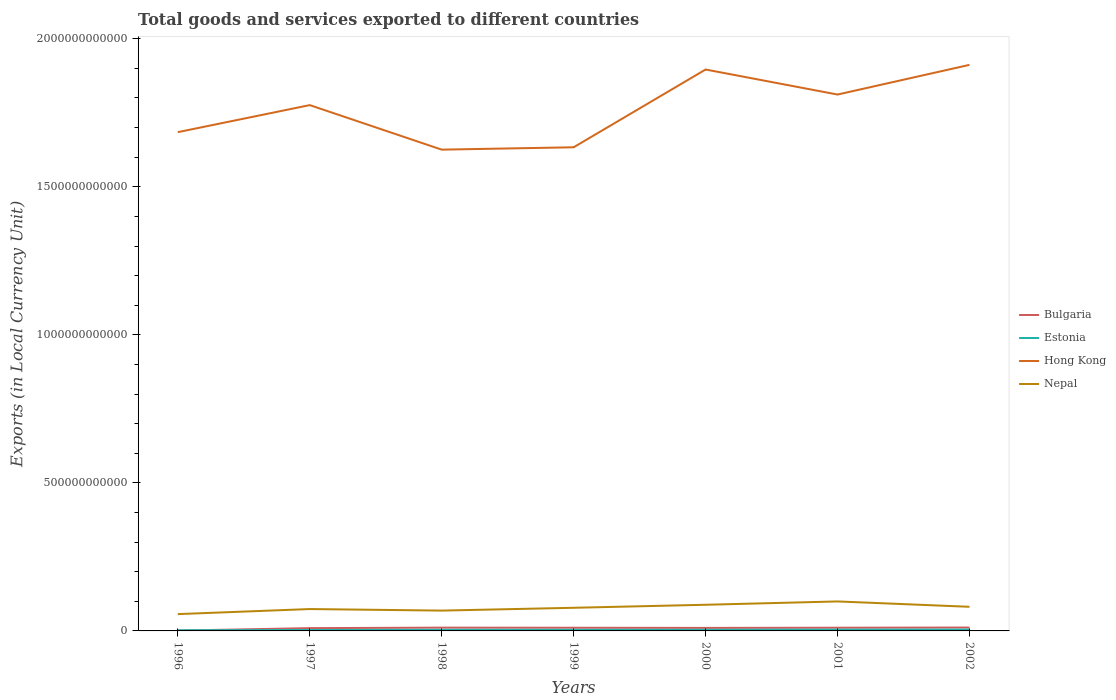Is the number of lines equal to the number of legend labels?
Provide a succinct answer. Yes. Across all years, what is the maximum Amount of goods and services exports in Estonia?
Give a very brief answer. 2.26e+09. In which year was the Amount of goods and services exports in Nepal maximum?
Your answer should be compact. 1996. What is the total Amount of goods and services exports in Bulgaria in the graph?
Provide a short and direct response. 2.89e+08. What is the difference between the highest and the second highest Amount of goods and services exports in Hong Kong?
Keep it short and to the point. 2.86e+11. Is the Amount of goods and services exports in Nepal strictly greater than the Amount of goods and services exports in Estonia over the years?
Provide a short and direct response. No. How many years are there in the graph?
Your response must be concise. 7. What is the difference between two consecutive major ticks on the Y-axis?
Make the answer very short. 5.00e+11. Are the values on the major ticks of Y-axis written in scientific E-notation?
Provide a short and direct response. No. Does the graph contain grids?
Offer a very short reply. No. Where does the legend appear in the graph?
Your answer should be very brief. Center right. What is the title of the graph?
Ensure brevity in your answer.  Total goods and services exported to different countries. What is the label or title of the Y-axis?
Ensure brevity in your answer.  Exports (in Local Currency Unit). What is the Exports (in Local Currency Unit) of Bulgaria in 1996?
Your answer should be very brief. 1.06e+09. What is the Exports (in Local Currency Unit) of Estonia in 1996?
Make the answer very short. 2.26e+09. What is the Exports (in Local Currency Unit) of Hong Kong in 1996?
Make the answer very short. 1.68e+12. What is the Exports (in Local Currency Unit) in Nepal in 1996?
Give a very brief answer. 5.68e+1. What is the Exports (in Local Currency Unit) in Bulgaria in 1997?
Give a very brief answer. 9.44e+09. What is the Exports (in Local Currency Unit) of Estonia in 1997?
Offer a very short reply. 3.22e+09. What is the Exports (in Local Currency Unit) of Hong Kong in 1997?
Provide a short and direct response. 1.78e+12. What is the Exports (in Local Currency Unit) of Nepal in 1997?
Offer a very short reply. 7.39e+1. What is the Exports (in Local Currency Unit) of Bulgaria in 1998?
Ensure brevity in your answer.  1.11e+1. What is the Exports (in Local Currency Unit) of Estonia in 1998?
Make the answer very short. 3.76e+09. What is the Exports (in Local Currency Unit) of Hong Kong in 1998?
Ensure brevity in your answer.  1.63e+12. What is the Exports (in Local Currency Unit) of Nepal in 1998?
Provide a short and direct response. 6.87e+1. What is the Exports (in Local Currency Unit) in Bulgaria in 1999?
Provide a short and direct response. 1.07e+1. What is the Exports (in Local Currency Unit) in Estonia in 1999?
Make the answer very short. 3.78e+09. What is the Exports (in Local Currency Unit) of Hong Kong in 1999?
Provide a short and direct response. 1.63e+12. What is the Exports (in Local Currency Unit) of Nepal in 1999?
Your response must be concise. 7.82e+1. What is the Exports (in Local Currency Unit) of Bulgaria in 2000?
Your answer should be compact. 1.02e+1. What is the Exports (in Local Currency Unit) in Estonia in 2000?
Your answer should be very brief. 3.80e+09. What is the Exports (in Local Currency Unit) in Hong Kong in 2000?
Ensure brevity in your answer.  1.90e+12. What is the Exports (in Local Currency Unit) of Nepal in 2000?
Your response must be concise. 8.84e+1. What is the Exports (in Local Currency Unit) in Bulgaria in 2001?
Your answer should be compact. 1.08e+1. What is the Exports (in Local Currency Unit) in Estonia in 2001?
Your answer should be compact. 4.28e+09. What is the Exports (in Local Currency Unit) in Hong Kong in 2001?
Give a very brief answer. 1.81e+12. What is the Exports (in Local Currency Unit) of Nepal in 2001?
Your answer should be compact. 9.96e+1. What is the Exports (in Local Currency Unit) of Bulgaria in 2002?
Your answer should be very brief. 1.15e+1. What is the Exports (in Local Currency Unit) of Estonia in 2002?
Your answer should be compact. 4.53e+09. What is the Exports (in Local Currency Unit) in Hong Kong in 2002?
Your response must be concise. 1.91e+12. What is the Exports (in Local Currency Unit) in Nepal in 2002?
Offer a terse response. 8.15e+1. Across all years, what is the maximum Exports (in Local Currency Unit) of Bulgaria?
Offer a very short reply. 1.15e+1. Across all years, what is the maximum Exports (in Local Currency Unit) in Estonia?
Provide a short and direct response. 4.53e+09. Across all years, what is the maximum Exports (in Local Currency Unit) in Hong Kong?
Provide a short and direct response. 1.91e+12. Across all years, what is the maximum Exports (in Local Currency Unit) in Nepal?
Offer a terse response. 9.96e+1. Across all years, what is the minimum Exports (in Local Currency Unit) in Bulgaria?
Offer a very short reply. 1.06e+09. Across all years, what is the minimum Exports (in Local Currency Unit) in Estonia?
Offer a very short reply. 2.26e+09. Across all years, what is the minimum Exports (in Local Currency Unit) of Hong Kong?
Your answer should be very brief. 1.63e+12. Across all years, what is the minimum Exports (in Local Currency Unit) in Nepal?
Provide a short and direct response. 5.68e+1. What is the total Exports (in Local Currency Unit) of Bulgaria in the graph?
Ensure brevity in your answer.  6.48e+1. What is the total Exports (in Local Currency Unit) of Estonia in the graph?
Ensure brevity in your answer.  2.56e+1. What is the total Exports (in Local Currency Unit) of Hong Kong in the graph?
Keep it short and to the point. 1.23e+13. What is the total Exports (in Local Currency Unit) in Nepal in the graph?
Offer a very short reply. 5.47e+11. What is the difference between the Exports (in Local Currency Unit) of Bulgaria in 1996 and that in 1997?
Give a very brief answer. -8.37e+09. What is the difference between the Exports (in Local Currency Unit) of Estonia in 1996 and that in 1997?
Offer a very short reply. -9.64e+08. What is the difference between the Exports (in Local Currency Unit) in Hong Kong in 1996 and that in 1997?
Ensure brevity in your answer.  -9.13e+1. What is the difference between the Exports (in Local Currency Unit) in Nepal in 1996 and that in 1997?
Keep it short and to the point. -1.71e+1. What is the difference between the Exports (in Local Currency Unit) of Bulgaria in 1996 and that in 1998?
Make the answer very short. -1.00e+1. What is the difference between the Exports (in Local Currency Unit) of Estonia in 1996 and that in 1998?
Ensure brevity in your answer.  -1.50e+09. What is the difference between the Exports (in Local Currency Unit) in Hong Kong in 1996 and that in 1998?
Provide a succinct answer. 5.90e+1. What is the difference between the Exports (in Local Currency Unit) in Nepal in 1996 and that in 1998?
Your answer should be compact. -1.19e+1. What is the difference between the Exports (in Local Currency Unit) of Bulgaria in 1996 and that in 1999?
Provide a short and direct response. -9.65e+09. What is the difference between the Exports (in Local Currency Unit) in Estonia in 1996 and that in 1999?
Provide a succinct answer. -1.52e+09. What is the difference between the Exports (in Local Currency Unit) of Hong Kong in 1996 and that in 1999?
Give a very brief answer. 5.11e+1. What is the difference between the Exports (in Local Currency Unit) of Nepal in 1996 and that in 1999?
Make the answer very short. -2.14e+1. What is the difference between the Exports (in Local Currency Unit) in Bulgaria in 1996 and that in 2000?
Offer a very short reply. -9.13e+09. What is the difference between the Exports (in Local Currency Unit) of Estonia in 1996 and that in 2000?
Your answer should be very brief. -1.55e+09. What is the difference between the Exports (in Local Currency Unit) of Hong Kong in 1996 and that in 2000?
Provide a short and direct response. -2.12e+11. What is the difference between the Exports (in Local Currency Unit) in Nepal in 1996 and that in 2000?
Your answer should be compact. -3.16e+1. What is the difference between the Exports (in Local Currency Unit) in Bulgaria in 1996 and that in 2001?
Provide a succinct answer. -9.75e+09. What is the difference between the Exports (in Local Currency Unit) of Estonia in 1996 and that in 2001?
Make the answer very short. -2.02e+09. What is the difference between the Exports (in Local Currency Unit) of Hong Kong in 1996 and that in 2001?
Make the answer very short. -1.27e+11. What is the difference between the Exports (in Local Currency Unit) of Nepal in 1996 and that in 2001?
Offer a very short reply. -4.28e+1. What is the difference between the Exports (in Local Currency Unit) of Bulgaria in 1996 and that in 2002?
Offer a terse response. -1.04e+1. What is the difference between the Exports (in Local Currency Unit) of Estonia in 1996 and that in 2002?
Make the answer very short. -2.28e+09. What is the difference between the Exports (in Local Currency Unit) in Hong Kong in 1996 and that in 2002?
Provide a short and direct response. -2.27e+11. What is the difference between the Exports (in Local Currency Unit) of Nepal in 1996 and that in 2002?
Your response must be concise. -2.47e+1. What is the difference between the Exports (in Local Currency Unit) in Bulgaria in 1997 and that in 1998?
Your response must be concise. -1.66e+09. What is the difference between the Exports (in Local Currency Unit) of Estonia in 1997 and that in 1998?
Make the answer very short. -5.37e+08. What is the difference between the Exports (in Local Currency Unit) in Hong Kong in 1997 and that in 1998?
Offer a terse response. 1.50e+11. What is the difference between the Exports (in Local Currency Unit) of Nepal in 1997 and that in 1998?
Keep it short and to the point. 5.19e+09. What is the difference between the Exports (in Local Currency Unit) of Bulgaria in 1997 and that in 1999?
Give a very brief answer. -1.27e+09. What is the difference between the Exports (in Local Currency Unit) in Estonia in 1997 and that in 1999?
Provide a short and direct response. -5.59e+08. What is the difference between the Exports (in Local Currency Unit) of Hong Kong in 1997 and that in 1999?
Provide a succinct answer. 1.42e+11. What is the difference between the Exports (in Local Currency Unit) of Nepal in 1997 and that in 1999?
Keep it short and to the point. -4.30e+09. What is the difference between the Exports (in Local Currency Unit) in Bulgaria in 1997 and that in 2000?
Your answer should be compact. -7.51e+08. What is the difference between the Exports (in Local Currency Unit) of Estonia in 1997 and that in 2000?
Give a very brief answer. -5.85e+08. What is the difference between the Exports (in Local Currency Unit) of Hong Kong in 1997 and that in 2000?
Your response must be concise. -1.20e+11. What is the difference between the Exports (in Local Currency Unit) of Nepal in 1997 and that in 2000?
Ensure brevity in your answer.  -1.45e+1. What is the difference between the Exports (in Local Currency Unit) in Bulgaria in 1997 and that in 2001?
Your response must be concise. -1.37e+09. What is the difference between the Exports (in Local Currency Unit) of Estonia in 1997 and that in 2001?
Your response must be concise. -1.06e+09. What is the difference between the Exports (in Local Currency Unit) of Hong Kong in 1997 and that in 2001?
Keep it short and to the point. -3.57e+1. What is the difference between the Exports (in Local Currency Unit) in Nepal in 1997 and that in 2001?
Your response must be concise. -2.57e+1. What is the difference between the Exports (in Local Currency Unit) in Bulgaria in 1997 and that in 2002?
Make the answer very short. -2.03e+09. What is the difference between the Exports (in Local Currency Unit) of Estonia in 1997 and that in 2002?
Keep it short and to the point. -1.32e+09. What is the difference between the Exports (in Local Currency Unit) in Hong Kong in 1997 and that in 2002?
Offer a terse response. -1.36e+11. What is the difference between the Exports (in Local Currency Unit) in Nepal in 1997 and that in 2002?
Offer a very short reply. -7.64e+09. What is the difference between the Exports (in Local Currency Unit) in Bulgaria in 1998 and that in 1999?
Give a very brief answer. 3.92e+08. What is the difference between the Exports (in Local Currency Unit) of Estonia in 1998 and that in 1999?
Give a very brief answer. -2.19e+07. What is the difference between the Exports (in Local Currency Unit) in Hong Kong in 1998 and that in 1999?
Your answer should be very brief. -7.95e+09. What is the difference between the Exports (in Local Currency Unit) of Nepal in 1998 and that in 1999?
Offer a terse response. -9.49e+09. What is the difference between the Exports (in Local Currency Unit) of Bulgaria in 1998 and that in 2000?
Your response must be concise. 9.11e+08. What is the difference between the Exports (in Local Currency Unit) of Estonia in 1998 and that in 2000?
Offer a terse response. -4.78e+07. What is the difference between the Exports (in Local Currency Unit) in Hong Kong in 1998 and that in 2000?
Make the answer very short. -2.71e+11. What is the difference between the Exports (in Local Currency Unit) of Nepal in 1998 and that in 2000?
Ensure brevity in your answer.  -1.97e+1. What is the difference between the Exports (in Local Currency Unit) in Bulgaria in 1998 and that in 2001?
Ensure brevity in your answer.  2.89e+08. What is the difference between the Exports (in Local Currency Unit) in Estonia in 1998 and that in 2001?
Your answer should be very brief. -5.24e+08. What is the difference between the Exports (in Local Currency Unit) of Hong Kong in 1998 and that in 2001?
Give a very brief answer. -1.86e+11. What is the difference between the Exports (in Local Currency Unit) of Nepal in 1998 and that in 2001?
Provide a short and direct response. -3.09e+1. What is the difference between the Exports (in Local Currency Unit) in Bulgaria in 1998 and that in 2002?
Your response must be concise. -3.66e+08. What is the difference between the Exports (in Local Currency Unit) in Estonia in 1998 and that in 2002?
Offer a terse response. -7.78e+08. What is the difference between the Exports (in Local Currency Unit) in Hong Kong in 1998 and that in 2002?
Provide a short and direct response. -2.86e+11. What is the difference between the Exports (in Local Currency Unit) of Nepal in 1998 and that in 2002?
Offer a very short reply. -1.28e+1. What is the difference between the Exports (in Local Currency Unit) of Bulgaria in 1999 and that in 2000?
Provide a short and direct response. 5.19e+08. What is the difference between the Exports (in Local Currency Unit) of Estonia in 1999 and that in 2000?
Offer a terse response. -2.58e+07. What is the difference between the Exports (in Local Currency Unit) in Hong Kong in 1999 and that in 2000?
Make the answer very short. -2.63e+11. What is the difference between the Exports (in Local Currency Unit) of Nepal in 1999 and that in 2000?
Make the answer very short. -1.02e+1. What is the difference between the Exports (in Local Currency Unit) of Bulgaria in 1999 and that in 2001?
Your response must be concise. -1.03e+08. What is the difference between the Exports (in Local Currency Unit) in Estonia in 1999 and that in 2001?
Give a very brief answer. -5.02e+08. What is the difference between the Exports (in Local Currency Unit) of Hong Kong in 1999 and that in 2001?
Provide a short and direct response. -1.78e+11. What is the difference between the Exports (in Local Currency Unit) in Nepal in 1999 and that in 2001?
Provide a short and direct response. -2.14e+1. What is the difference between the Exports (in Local Currency Unit) in Bulgaria in 1999 and that in 2002?
Provide a short and direct response. -7.57e+08. What is the difference between the Exports (in Local Currency Unit) of Estonia in 1999 and that in 2002?
Your response must be concise. -7.56e+08. What is the difference between the Exports (in Local Currency Unit) of Hong Kong in 1999 and that in 2002?
Your answer should be very brief. -2.78e+11. What is the difference between the Exports (in Local Currency Unit) in Nepal in 1999 and that in 2002?
Make the answer very short. -3.34e+09. What is the difference between the Exports (in Local Currency Unit) of Bulgaria in 2000 and that in 2001?
Ensure brevity in your answer.  -6.22e+08. What is the difference between the Exports (in Local Currency Unit) in Estonia in 2000 and that in 2001?
Ensure brevity in your answer.  -4.76e+08. What is the difference between the Exports (in Local Currency Unit) of Hong Kong in 2000 and that in 2001?
Keep it short and to the point. 8.45e+1. What is the difference between the Exports (in Local Currency Unit) of Nepal in 2000 and that in 2001?
Keep it short and to the point. -1.12e+1. What is the difference between the Exports (in Local Currency Unit) in Bulgaria in 2000 and that in 2002?
Provide a succinct answer. -1.28e+09. What is the difference between the Exports (in Local Currency Unit) in Estonia in 2000 and that in 2002?
Your response must be concise. -7.30e+08. What is the difference between the Exports (in Local Currency Unit) of Hong Kong in 2000 and that in 2002?
Provide a succinct answer. -1.57e+1. What is the difference between the Exports (in Local Currency Unit) of Nepal in 2000 and that in 2002?
Provide a short and direct response. 6.87e+09. What is the difference between the Exports (in Local Currency Unit) in Bulgaria in 2001 and that in 2002?
Keep it short and to the point. -6.55e+08. What is the difference between the Exports (in Local Currency Unit) in Estonia in 2001 and that in 2002?
Provide a short and direct response. -2.54e+08. What is the difference between the Exports (in Local Currency Unit) in Hong Kong in 2001 and that in 2002?
Your answer should be compact. -1.00e+11. What is the difference between the Exports (in Local Currency Unit) in Nepal in 2001 and that in 2002?
Provide a succinct answer. 1.81e+1. What is the difference between the Exports (in Local Currency Unit) of Bulgaria in 1996 and the Exports (in Local Currency Unit) of Estonia in 1997?
Ensure brevity in your answer.  -2.16e+09. What is the difference between the Exports (in Local Currency Unit) in Bulgaria in 1996 and the Exports (in Local Currency Unit) in Hong Kong in 1997?
Offer a terse response. -1.77e+12. What is the difference between the Exports (in Local Currency Unit) of Bulgaria in 1996 and the Exports (in Local Currency Unit) of Nepal in 1997?
Ensure brevity in your answer.  -7.28e+1. What is the difference between the Exports (in Local Currency Unit) in Estonia in 1996 and the Exports (in Local Currency Unit) in Hong Kong in 1997?
Your answer should be compact. -1.77e+12. What is the difference between the Exports (in Local Currency Unit) in Estonia in 1996 and the Exports (in Local Currency Unit) in Nepal in 1997?
Ensure brevity in your answer.  -7.16e+1. What is the difference between the Exports (in Local Currency Unit) of Hong Kong in 1996 and the Exports (in Local Currency Unit) of Nepal in 1997?
Offer a very short reply. 1.61e+12. What is the difference between the Exports (in Local Currency Unit) in Bulgaria in 1996 and the Exports (in Local Currency Unit) in Estonia in 1998?
Give a very brief answer. -2.69e+09. What is the difference between the Exports (in Local Currency Unit) in Bulgaria in 1996 and the Exports (in Local Currency Unit) in Hong Kong in 1998?
Offer a terse response. -1.62e+12. What is the difference between the Exports (in Local Currency Unit) of Bulgaria in 1996 and the Exports (in Local Currency Unit) of Nepal in 1998?
Keep it short and to the point. -6.76e+1. What is the difference between the Exports (in Local Currency Unit) in Estonia in 1996 and the Exports (in Local Currency Unit) in Hong Kong in 1998?
Give a very brief answer. -1.62e+12. What is the difference between the Exports (in Local Currency Unit) in Estonia in 1996 and the Exports (in Local Currency Unit) in Nepal in 1998?
Offer a very short reply. -6.64e+1. What is the difference between the Exports (in Local Currency Unit) in Hong Kong in 1996 and the Exports (in Local Currency Unit) in Nepal in 1998?
Make the answer very short. 1.62e+12. What is the difference between the Exports (in Local Currency Unit) of Bulgaria in 1996 and the Exports (in Local Currency Unit) of Estonia in 1999?
Make the answer very short. -2.72e+09. What is the difference between the Exports (in Local Currency Unit) of Bulgaria in 1996 and the Exports (in Local Currency Unit) of Hong Kong in 1999?
Your answer should be very brief. -1.63e+12. What is the difference between the Exports (in Local Currency Unit) of Bulgaria in 1996 and the Exports (in Local Currency Unit) of Nepal in 1999?
Give a very brief answer. -7.71e+1. What is the difference between the Exports (in Local Currency Unit) in Estonia in 1996 and the Exports (in Local Currency Unit) in Hong Kong in 1999?
Offer a very short reply. -1.63e+12. What is the difference between the Exports (in Local Currency Unit) of Estonia in 1996 and the Exports (in Local Currency Unit) of Nepal in 1999?
Make the answer very short. -7.59e+1. What is the difference between the Exports (in Local Currency Unit) of Hong Kong in 1996 and the Exports (in Local Currency Unit) of Nepal in 1999?
Make the answer very short. 1.61e+12. What is the difference between the Exports (in Local Currency Unit) of Bulgaria in 1996 and the Exports (in Local Currency Unit) of Estonia in 2000?
Keep it short and to the point. -2.74e+09. What is the difference between the Exports (in Local Currency Unit) in Bulgaria in 1996 and the Exports (in Local Currency Unit) in Hong Kong in 2000?
Give a very brief answer. -1.90e+12. What is the difference between the Exports (in Local Currency Unit) in Bulgaria in 1996 and the Exports (in Local Currency Unit) in Nepal in 2000?
Provide a short and direct response. -8.73e+1. What is the difference between the Exports (in Local Currency Unit) of Estonia in 1996 and the Exports (in Local Currency Unit) of Hong Kong in 2000?
Your response must be concise. -1.89e+12. What is the difference between the Exports (in Local Currency Unit) in Estonia in 1996 and the Exports (in Local Currency Unit) in Nepal in 2000?
Ensure brevity in your answer.  -8.61e+1. What is the difference between the Exports (in Local Currency Unit) in Hong Kong in 1996 and the Exports (in Local Currency Unit) in Nepal in 2000?
Ensure brevity in your answer.  1.60e+12. What is the difference between the Exports (in Local Currency Unit) in Bulgaria in 1996 and the Exports (in Local Currency Unit) in Estonia in 2001?
Offer a terse response. -3.22e+09. What is the difference between the Exports (in Local Currency Unit) of Bulgaria in 1996 and the Exports (in Local Currency Unit) of Hong Kong in 2001?
Provide a short and direct response. -1.81e+12. What is the difference between the Exports (in Local Currency Unit) in Bulgaria in 1996 and the Exports (in Local Currency Unit) in Nepal in 2001?
Offer a terse response. -9.85e+1. What is the difference between the Exports (in Local Currency Unit) in Estonia in 1996 and the Exports (in Local Currency Unit) in Hong Kong in 2001?
Ensure brevity in your answer.  -1.81e+12. What is the difference between the Exports (in Local Currency Unit) in Estonia in 1996 and the Exports (in Local Currency Unit) in Nepal in 2001?
Provide a short and direct response. -9.73e+1. What is the difference between the Exports (in Local Currency Unit) in Hong Kong in 1996 and the Exports (in Local Currency Unit) in Nepal in 2001?
Make the answer very short. 1.58e+12. What is the difference between the Exports (in Local Currency Unit) in Bulgaria in 1996 and the Exports (in Local Currency Unit) in Estonia in 2002?
Your answer should be very brief. -3.47e+09. What is the difference between the Exports (in Local Currency Unit) in Bulgaria in 1996 and the Exports (in Local Currency Unit) in Hong Kong in 2002?
Your response must be concise. -1.91e+12. What is the difference between the Exports (in Local Currency Unit) of Bulgaria in 1996 and the Exports (in Local Currency Unit) of Nepal in 2002?
Offer a terse response. -8.04e+1. What is the difference between the Exports (in Local Currency Unit) of Estonia in 1996 and the Exports (in Local Currency Unit) of Hong Kong in 2002?
Offer a terse response. -1.91e+12. What is the difference between the Exports (in Local Currency Unit) in Estonia in 1996 and the Exports (in Local Currency Unit) in Nepal in 2002?
Your response must be concise. -7.92e+1. What is the difference between the Exports (in Local Currency Unit) in Hong Kong in 1996 and the Exports (in Local Currency Unit) in Nepal in 2002?
Provide a short and direct response. 1.60e+12. What is the difference between the Exports (in Local Currency Unit) in Bulgaria in 1997 and the Exports (in Local Currency Unit) in Estonia in 1998?
Offer a very short reply. 5.68e+09. What is the difference between the Exports (in Local Currency Unit) in Bulgaria in 1997 and the Exports (in Local Currency Unit) in Hong Kong in 1998?
Your response must be concise. -1.62e+12. What is the difference between the Exports (in Local Currency Unit) of Bulgaria in 1997 and the Exports (in Local Currency Unit) of Nepal in 1998?
Your response must be concise. -5.92e+1. What is the difference between the Exports (in Local Currency Unit) in Estonia in 1997 and the Exports (in Local Currency Unit) in Hong Kong in 1998?
Make the answer very short. -1.62e+12. What is the difference between the Exports (in Local Currency Unit) in Estonia in 1997 and the Exports (in Local Currency Unit) in Nepal in 1998?
Your answer should be very brief. -6.54e+1. What is the difference between the Exports (in Local Currency Unit) in Hong Kong in 1997 and the Exports (in Local Currency Unit) in Nepal in 1998?
Your response must be concise. 1.71e+12. What is the difference between the Exports (in Local Currency Unit) of Bulgaria in 1997 and the Exports (in Local Currency Unit) of Estonia in 1999?
Keep it short and to the point. 5.66e+09. What is the difference between the Exports (in Local Currency Unit) of Bulgaria in 1997 and the Exports (in Local Currency Unit) of Hong Kong in 1999?
Offer a very short reply. -1.62e+12. What is the difference between the Exports (in Local Currency Unit) of Bulgaria in 1997 and the Exports (in Local Currency Unit) of Nepal in 1999?
Provide a short and direct response. -6.87e+1. What is the difference between the Exports (in Local Currency Unit) of Estonia in 1997 and the Exports (in Local Currency Unit) of Hong Kong in 1999?
Give a very brief answer. -1.63e+12. What is the difference between the Exports (in Local Currency Unit) of Estonia in 1997 and the Exports (in Local Currency Unit) of Nepal in 1999?
Keep it short and to the point. -7.49e+1. What is the difference between the Exports (in Local Currency Unit) of Hong Kong in 1997 and the Exports (in Local Currency Unit) of Nepal in 1999?
Your response must be concise. 1.70e+12. What is the difference between the Exports (in Local Currency Unit) of Bulgaria in 1997 and the Exports (in Local Currency Unit) of Estonia in 2000?
Offer a terse response. 5.63e+09. What is the difference between the Exports (in Local Currency Unit) of Bulgaria in 1997 and the Exports (in Local Currency Unit) of Hong Kong in 2000?
Your answer should be compact. -1.89e+12. What is the difference between the Exports (in Local Currency Unit) in Bulgaria in 1997 and the Exports (in Local Currency Unit) in Nepal in 2000?
Offer a very short reply. -7.89e+1. What is the difference between the Exports (in Local Currency Unit) of Estonia in 1997 and the Exports (in Local Currency Unit) of Hong Kong in 2000?
Offer a terse response. -1.89e+12. What is the difference between the Exports (in Local Currency Unit) of Estonia in 1997 and the Exports (in Local Currency Unit) of Nepal in 2000?
Offer a terse response. -8.51e+1. What is the difference between the Exports (in Local Currency Unit) in Hong Kong in 1997 and the Exports (in Local Currency Unit) in Nepal in 2000?
Give a very brief answer. 1.69e+12. What is the difference between the Exports (in Local Currency Unit) of Bulgaria in 1997 and the Exports (in Local Currency Unit) of Estonia in 2001?
Provide a short and direct response. 5.16e+09. What is the difference between the Exports (in Local Currency Unit) of Bulgaria in 1997 and the Exports (in Local Currency Unit) of Hong Kong in 2001?
Your answer should be very brief. -1.80e+12. What is the difference between the Exports (in Local Currency Unit) of Bulgaria in 1997 and the Exports (in Local Currency Unit) of Nepal in 2001?
Give a very brief answer. -9.01e+1. What is the difference between the Exports (in Local Currency Unit) in Estonia in 1997 and the Exports (in Local Currency Unit) in Hong Kong in 2001?
Give a very brief answer. -1.81e+12. What is the difference between the Exports (in Local Currency Unit) in Estonia in 1997 and the Exports (in Local Currency Unit) in Nepal in 2001?
Make the answer very short. -9.64e+1. What is the difference between the Exports (in Local Currency Unit) of Hong Kong in 1997 and the Exports (in Local Currency Unit) of Nepal in 2001?
Provide a succinct answer. 1.68e+12. What is the difference between the Exports (in Local Currency Unit) of Bulgaria in 1997 and the Exports (in Local Currency Unit) of Estonia in 2002?
Your response must be concise. 4.90e+09. What is the difference between the Exports (in Local Currency Unit) of Bulgaria in 1997 and the Exports (in Local Currency Unit) of Hong Kong in 2002?
Provide a succinct answer. -1.90e+12. What is the difference between the Exports (in Local Currency Unit) in Bulgaria in 1997 and the Exports (in Local Currency Unit) in Nepal in 2002?
Provide a succinct answer. -7.21e+1. What is the difference between the Exports (in Local Currency Unit) in Estonia in 1997 and the Exports (in Local Currency Unit) in Hong Kong in 2002?
Your response must be concise. -1.91e+12. What is the difference between the Exports (in Local Currency Unit) in Estonia in 1997 and the Exports (in Local Currency Unit) in Nepal in 2002?
Offer a very short reply. -7.83e+1. What is the difference between the Exports (in Local Currency Unit) of Hong Kong in 1997 and the Exports (in Local Currency Unit) of Nepal in 2002?
Offer a very short reply. 1.69e+12. What is the difference between the Exports (in Local Currency Unit) in Bulgaria in 1998 and the Exports (in Local Currency Unit) in Estonia in 1999?
Offer a very short reply. 7.32e+09. What is the difference between the Exports (in Local Currency Unit) in Bulgaria in 1998 and the Exports (in Local Currency Unit) in Hong Kong in 1999?
Ensure brevity in your answer.  -1.62e+12. What is the difference between the Exports (in Local Currency Unit) in Bulgaria in 1998 and the Exports (in Local Currency Unit) in Nepal in 1999?
Make the answer very short. -6.71e+1. What is the difference between the Exports (in Local Currency Unit) in Estonia in 1998 and the Exports (in Local Currency Unit) in Hong Kong in 1999?
Provide a succinct answer. -1.63e+12. What is the difference between the Exports (in Local Currency Unit) of Estonia in 1998 and the Exports (in Local Currency Unit) of Nepal in 1999?
Your answer should be very brief. -7.44e+1. What is the difference between the Exports (in Local Currency Unit) of Hong Kong in 1998 and the Exports (in Local Currency Unit) of Nepal in 1999?
Provide a succinct answer. 1.55e+12. What is the difference between the Exports (in Local Currency Unit) of Bulgaria in 1998 and the Exports (in Local Currency Unit) of Estonia in 2000?
Your answer should be very brief. 7.29e+09. What is the difference between the Exports (in Local Currency Unit) in Bulgaria in 1998 and the Exports (in Local Currency Unit) in Hong Kong in 2000?
Your answer should be very brief. -1.88e+12. What is the difference between the Exports (in Local Currency Unit) in Bulgaria in 1998 and the Exports (in Local Currency Unit) in Nepal in 2000?
Your answer should be compact. -7.73e+1. What is the difference between the Exports (in Local Currency Unit) in Estonia in 1998 and the Exports (in Local Currency Unit) in Hong Kong in 2000?
Offer a terse response. -1.89e+12. What is the difference between the Exports (in Local Currency Unit) of Estonia in 1998 and the Exports (in Local Currency Unit) of Nepal in 2000?
Make the answer very short. -8.46e+1. What is the difference between the Exports (in Local Currency Unit) of Hong Kong in 1998 and the Exports (in Local Currency Unit) of Nepal in 2000?
Provide a short and direct response. 1.54e+12. What is the difference between the Exports (in Local Currency Unit) in Bulgaria in 1998 and the Exports (in Local Currency Unit) in Estonia in 2001?
Make the answer very short. 6.82e+09. What is the difference between the Exports (in Local Currency Unit) in Bulgaria in 1998 and the Exports (in Local Currency Unit) in Hong Kong in 2001?
Your answer should be very brief. -1.80e+12. What is the difference between the Exports (in Local Currency Unit) in Bulgaria in 1998 and the Exports (in Local Currency Unit) in Nepal in 2001?
Provide a succinct answer. -8.85e+1. What is the difference between the Exports (in Local Currency Unit) in Estonia in 1998 and the Exports (in Local Currency Unit) in Hong Kong in 2001?
Give a very brief answer. -1.81e+12. What is the difference between the Exports (in Local Currency Unit) of Estonia in 1998 and the Exports (in Local Currency Unit) of Nepal in 2001?
Keep it short and to the point. -9.58e+1. What is the difference between the Exports (in Local Currency Unit) of Hong Kong in 1998 and the Exports (in Local Currency Unit) of Nepal in 2001?
Provide a succinct answer. 1.53e+12. What is the difference between the Exports (in Local Currency Unit) of Bulgaria in 1998 and the Exports (in Local Currency Unit) of Estonia in 2002?
Provide a short and direct response. 6.56e+09. What is the difference between the Exports (in Local Currency Unit) of Bulgaria in 1998 and the Exports (in Local Currency Unit) of Hong Kong in 2002?
Your answer should be compact. -1.90e+12. What is the difference between the Exports (in Local Currency Unit) of Bulgaria in 1998 and the Exports (in Local Currency Unit) of Nepal in 2002?
Your answer should be very brief. -7.04e+1. What is the difference between the Exports (in Local Currency Unit) in Estonia in 1998 and the Exports (in Local Currency Unit) in Hong Kong in 2002?
Your answer should be compact. -1.91e+12. What is the difference between the Exports (in Local Currency Unit) in Estonia in 1998 and the Exports (in Local Currency Unit) in Nepal in 2002?
Ensure brevity in your answer.  -7.77e+1. What is the difference between the Exports (in Local Currency Unit) of Hong Kong in 1998 and the Exports (in Local Currency Unit) of Nepal in 2002?
Keep it short and to the point. 1.54e+12. What is the difference between the Exports (in Local Currency Unit) in Bulgaria in 1999 and the Exports (in Local Currency Unit) in Estonia in 2000?
Give a very brief answer. 6.90e+09. What is the difference between the Exports (in Local Currency Unit) of Bulgaria in 1999 and the Exports (in Local Currency Unit) of Hong Kong in 2000?
Your response must be concise. -1.89e+12. What is the difference between the Exports (in Local Currency Unit) in Bulgaria in 1999 and the Exports (in Local Currency Unit) in Nepal in 2000?
Ensure brevity in your answer.  -7.77e+1. What is the difference between the Exports (in Local Currency Unit) in Estonia in 1999 and the Exports (in Local Currency Unit) in Hong Kong in 2000?
Your response must be concise. -1.89e+12. What is the difference between the Exports (in Local Currency Unit) in Estonia in 1999 and the Exports (in Local Currency Unit) in Nepal in 2000?
Make the answer very short. -8.46e+1. What is the difference between the Exports (in Local Currency Unit) in Hong Kong in 1999 and the Exports (in Local Currency Unit) in Nepal in 2000?
Make the answer very short. 1.55e+12. What is the difference between the Exports (in Local Currency Unit) of Bulgaria in 1999 and the Exports (in Local Currency Unit) of Estonia in 2001?
Your answer should be very brief. 6.43e+09. What is the difference between the Exports (in Local Currency Unit) of Bulgaria in 1999 and the Exports (in Local Currency Unit) of Hong Kong in 2001?
Make the answer very short. -1.80e+12. What is the difference between the Exports (in Local Currency Unit) in Bulgaria in 1999 and the Exports (in Local Currency Unit) in Nepal in 2001?
Your answer should be compact. -8.89e+1. What is the difference between the Exports (in Local Currency Unit) in Estonia in 1999 and the Exports (in Local Currency Unit) in Hong Kong in 2001?
Keep it short and to the point. -1.81e+12. What is the difference between the Exports (in Local Currency Unit) in Estonia in 1999 and the Exports (in Local Currency Unit) in Nepal in 2001?
Ensure brevity in your answer.  -9.58e+1. What is the difference between the Exports (in Local Currency Unit) in Hong Kong in 1999 and the Exports (in Local Currency Unit) in Nepal in 2001?
Offer a terse response. 1.53e+12. What is the difference between the Exports (in Local Currency Unit) of Bulgaria in 1999 and the Exports (in Local Currency Unit) of Estonia in 2002?
Provide a short and direct response. 6.17e+09. What is the difference between the Exports (in Local Currency Unit) of Bulgaria in 1999 and the Exports (in Local Currency Unit) of Hong Kong in 2002?
Make the answer very short. -1.90e+12. What is the difference between the Exports (in Local Currency Unit) of Bulgaria in 1999 and the Exports (in Local Currency Unit) of Nepal in 2002?
Your response must be concise. -7.08e+1. What is the difference between the Exports (in Local Currency Unit) in Estonia in 1999 and the Exports (in Local Currency Unit) in Hong Kong in 2002?
Offer a very short reply. -1.91e+12. What is the difference between the Exports (in Local Currency Unit) in Estonia in 1999 and the Exports (in Local Currency Unit) in Nepal in 2002?
Give a very brief answer. -7.77e+1. What is the difference between the Exports (in Local Currency Unit) of Hong Kong in 1999 and the Exports (in Local Currency Unit) of Nepal in 2002?
Provide a short and direct response. 1.55e+12. What is the difference between the Exports (in Local Currency Unit) in Bulgaria in 2000 and the Exports (in Local Currency Unit) in Estonia in 2001?
Give a very brief answer. 5.91e+09. What is the difference between the Exports (in Local Currency Unit) in Bulgaria in 2000 and the Exports (in Local Currency Unit) in Hong Kong in 2001?
Keep it short and to the point. -1.80e+12. What is the difference between the Exports (in Local Currency Unit) of Bulgaria in 2000 and the Exports (in Local Currency Unit) of Nepal in 2001?
Ensure brevity in your answer.  -8.94e+1. What is the difference between the Exports (in Local Currency Unit) of Estonia in 2000 and the Exports (in Local Currency Unit) of Hong Kong in 2001?
Provide a succinct answer. -1.81e+12. What is the difference between the Exports (in Local Currency Unit) in Estonia in 2000 and the Exports (in Local Currency Unit) in Nepal in 2001?
Provide a succinct answer. -9.58e+1. What is the difference between the Exports (in Local Currency Unit) of Hong Kong in 2000 and the Exports (in Local Currency Unit) of Nepal in 2001?
Keep it short and to the point. 1.80e+12. What is the difference between the Exports (in Local Currency Unit) in Bulgaria in 2000 and the Exports (in Local Currency Unit) in Estonia in 2002?
Your answer should be very brief. 5.65e+09. What is the difference between the Exports (in Local Currency Unit) of Bulgaria in 2000 and the Exports (in Local Currency Unit) of Hong Kong in 2002?
Your answer should be very brief. -1.90e+12. What is the difference between the Exports (in Local Currency Unit) of Bulgaria in 2000 and the Exports (in Local Currency Unit) of Nepal in 2002?
Offer a terse response. -7.13e+1. What is the difference between the Exports (in Local Currency Unit) in Estonia in 2000 and the Exports (in Local Currency Unit) in Hong Kong in 2002?
Your response must be concise. -1.91e+12. What is the difference between the Exports (in Local Currency Unit) in Estonia in 2000 and the Exports (in Local Currency Unit) in Nepal in 2002?
Offer a terse response. -7.77e+1. What is the difference between the Exports (in Local Currency Unit) in Hong Kong in 2000 and the Exports (in Local Currency Unit) in Nepal in 2002?
Ensure brevity in your answer.  1.81e+12. What is the difference between the Exports (in Local Currency Unit) of Bulgaria in 2001 and the Exports (in Local Currency Unit) of Estonia in 2002?
Give a very brief answer. 6.27e+09. What is the difference between the Exports (in Local Currency Unit) of Bulgaria in 2001 and the Exports (in Local Currency Unit) of Hong Kong in 2002?
Keep it short and to the point. -1.90e+12. What is the difference between the Exports (in Local Currency Unit) of Bulgaria in 2001 and the Exports (in Local Currency Unit) of Nepal in 2002?
Your answer should be very brief. -7.07e+1. What is the difference between the Exports (in Local Currency Unit) in Estonia in 2001 and the Exports (in Local Currency Unit) in Hong Kong in 2002?
Your answer should be very brief. -1.91e+12. What is the difference between the Exports (in Local Currency Unit) of Estonia in 2001 and the Exports (in Local Currency Unit) of Nepal in 2002?
Provide a succinct answer. -7.72e+1. What is the difference between the Exports (in Local Currency Unit) in Hong Kong in 2001 and the Exports (in Local Currency Unit) in Nepal in 2002?
Ensure brevity in your answer.  1.73e+12. What is the average Exports (in Local Currency Unit) of Bulgaria per year?
Your answer should be very brief. 9.25e+09. What is the average Exports (in Local Currency Unit) of Estonia per year?
Provide a succinct answer. 3.66e+09. What is the average Exports (in Local Currency Unit) of Hong Kong per year?
Your answer should be compact. 1.76e+12. What is the average Exports (in Local Currency Unit) in Nepal per year?
Provide a succinct answer. 7.81e+1. In the year 1996, what is the difference between the Exports (in Local Currency Unit) of Bulgaria and Exports (in Local Currency Unit) of Estonia?
Provide a succinct answer. -1.19e+09. In the year 1996, what is the difference between the Exports (in Local Currency Unit) of Bulgaria and Exports (in Local Currency Unit) of Hong Kong?
Offer a terse response. -1.68e+12. In the year 1996, what is the difference between the Exports (in Local Currency Unit) in Bulgaria and Exports (in Local Currency Unit) in Nepal?
Your answer should be very brief. -5.57e+1. In the year 1996, what is the difference between the Exports (in Local Currency Unit) in Estonia and Exports (in Local Currency Unit) in Hong Kong?
Your answer should be compact. -1.68e+12. In the year 1996, what is the difference between the Exports (in Local Currency Unit) in Estonia and Exports (in Local Currency Unit) in Nepal?
Make the answer very short. -5.45e+1. In the year 1996, what is the difference between the Exports (in Local Currency Unit) of Hong Kong and Exports (in Local Currency Unit) of Nepal?
Offer a terse response. 1.63e+12. In the year 1997, what is the difference between the Exports (in Local Currency Unit) of Bulgaria and Exports (in Local Currency Unit) of Estonia?
Give a very brief answer. 6.22e+09. In the year 1997, what is the difference between the Exports (in Local Currency Unit) of Bulgaria and Exports (in Local Currency Unit) of Hong Kong?
Provide a short and direct response. -1.77e+12. In the year 1997, what is the difference between the Exports (in Local Currency Unit) of Bulgaria and Exports (in Local Currency Unit) of Nepal?
Your answer should be compact. -6.44e+1. In the year 1997, what is the difference between the Exports (in Local Currency Unit) in Estonia and Exports (in Local Currency Unit) in Hong Kong?
Keep it short and to the point. -1.77e+12. In the year 1997, what is the difference between the Exports (in Local Currency Unit) of Estonia and Exports (in Local Currency Unit) of Nepal?
Offer a very short reply. -7.06e+1. In the year 1997, what is the difference between the Exports (in Local Currency Unit) of Hong Kong and Exports (in Local Currency Unit) of Nepal?
Make the answer very short. 1.70e+12. In the year 1998, what is the difference between the Exports (in Local Currency Unit) in Bulgaria and Exports (in Local Currency Unit) in Estonia?
Give a very brief answer. 7.34e+09. In the year 1998, what is the difference between the Exports (in Local Currency Unit) of Bulgaria and Exports (in Local Currency Unit) of Hong Kong?
Make the answer very short. -1.61e+12. In the year 1998, what is the difference between the Exports (in Local Currency Unit) in Bulgaria and Exports (in Local Currency Unit) in Nepal?
Offer a very short reply. -5.76e+1. In the year 1998, what is the difference between the Exports (in Local Currency Unit) in Estonia and Exports (in Local Currency Unit) in Hong Kong?
Provide a succinct answer. -1.62e+12. In the year 1998, what is the difference between the Exports (in Local Currency Unit) of Estonia and Exports (in Local Currency Unit) of Nepal?
Your answer should be very brief. -6.49e+1. In the year 1998, what is the difference between the Exports (in Local Currency Unit) of Hong Kong and Exports (in Local Currency Unit) of Nepal?
Make the answer very short. 1.56e+12. In the year 1999, what is the difference between the Exports (in Local Currency Unit) in Bulgaria and Exports (in Local Currency Unit) in Estonia?
Your answer should be very brief. 6.93e+09. In the year 1999, what is the difference between the Exports (in Local Currency Unit) of Bulgaria and Exports (in Local Currency Unit) of Hong Kong?
Offer a very short reply. -1.62e+12. In the year 1999, what is the difference between the Exports (in Local Currency Unit) in Bulgaria and Exports (in Local Currency Unit) in Nepal?
Your response must be concise. -6.74e+1. In the year 1999, what is the difference between the Exports (in Local Currency Unit) in Estonia and Exports (in Local Currency Unit) in Hong Kong?
Ensure brevity in your answer.  -1.63e+12. In the year 1999, what is the difference between the Exports (in Local Currency Unit) in Estonia and Exports (in Local Currency Unit) in Nepal?
Make the answer very short. -7.44e+1. In the year 1999, what is the difference between the Exports (in Local Currency Unit) in Hong Kong and Exports (in Local Currency Unit) in Nepal?
Your answer should be very brief. 1.56e+12. In the year 2000, what is the difference between the Exports (in Local Currency Unit) of Bulgaria and Exports (in Local Currency Unit) of Estonia?
Ensure brevity in your answer.  6.38e+09. In the year 2000, what is the difference between the Exports (in Local Currency Unit) in Bulgaria and Exports (in Local Currency Unit) in Hong Kong?
Ensure brevity in your answer.  -1.89e+12. In the year 2000, what is the difference between the Exports (in Local Currency Unit) in Bulgaria and Exports (in Local Currency Unit) in Nepal?
Provide a succinct answer. -7.82e+1. In the year 2000, what is the difference between the Exports (in Local Currency Unit) in Estonia and Exports (in Local Currency Unit) in Hong Kong?
Provide a short and direct response. -1.89e+12. In the year 2000, what is the difference between the Exports (in Local Currency Unit) in Estonia and Exports (in Local Currency Unit) in Nepal?
Provide a succinct answer. -8.46e+1. In the year 2000, what is the difference between the Exports (in Local Currency Unit) of Hong Kong and Exports (in Local Currency Unit) of Nepal?
Your answer should be very brief. 1.81e+12. In the year 2001, what is the difference between the Exports (in Local Currency Unit) of Bulgaria and Exports (in Local Currency Unit) of Estonia?
Keep it short and to the point. 6.53e+09. In the year 2001, what is the difference between the Exports (in Local Currency Unit) in Bulgaria and Exports (in Local Currency Unit) in Hong Kong?
Your answer should be very brief. -1.80e+12. In the year 2001, what is the difference between the Exports (in Local Currency Unit) of Bulgaria and Exports (in Local Currency Unit) of Nepal?
Keep it short and to the point. -8.88e+1. In the year 2001, what is the difference between the Exports (in Local Currency Unit) of Estonia and Exports (in Local Currency Unit) of Hong Kong?
Keep it short and to the point. -1.81e+12. In the year 2001, what is the difference between the Exports (in Local Currency Unit) in Estonia and Exports (in Local Currency Unit) in Nepal?
Your answer should be very brief. -9.53e+1. In the year 2001, what is the difference between the Exports (in Local Currency Unit) in Hong Kong and Exports (in Local Currency Unit) in Nepal?
Your answer should be compact. 1.71e+12. In the year 2002, what is the difference between the Exports (in Local Currency Unit) in Bulgaria and Exports (in Local Currency Unit) in Estonia?
Offer a terse response. 6.93e+09. In the year 2002, what is the difference between the Exports (in Local Currency Unit) of Bulgaria and Exports (in Local Currency Unit) of Hong Kong?
Provide a succinct answer. -1.90e+12. In the year 2002, what is the difference between the Exports (in Local Currency Unit) in Bulgaria and Exports (in Local Currency Unit) in Nepal?
Your response must be concise. -7.00e+1. In the year 2002, what is the difference between the Exports (in Local Currency Unit) in Estonia and Exports (in Local Currency Unit) in Hong Kong?
Provide a short and direct response. -1.91e+12. In the year 2002, what is the difference between the Exports (in Local Currency Unit) of Estonia and Exports (in Local Currency Unit) of Nepal?
Give a very brief answer. -7.70e+1. In the year 2002, what is the difference between the Exports (in Local Currency Unit) in Hong Kong and Exports (in Local Currency Unit) in Nepal?
Provide a succinct answer. 1.83e+12. What is the ratio of the Exports (in Local Currency Unit) of Bulgaria in 1996 to that in 1997?
Give a very brief answer. 0.11. What is the ratio of the Exports (in Local Currency Unit) in Estonia in 1996 to that in 1997?
Give a very brief answer. 0.7. What is the ratio of the Exports (in Local Currency Unit) in Hong Kong in 1996 to that in 1997?
Make the answer very short. 0.95. What is the ratio of the Exports (in Local Currency Unit) of Nepal in 1996 to that in 1997?
Your response must be concise. 0.77. What is the ratio of the Exports (in Local Currency Unit) of Bulgaria in 1996 to that in 1998?
Provide a succinct answer. 0.1. What is the ratio of the Exports (in Local Currency Unit) in Estonia in 1996 to that in 1998?
Make the answer very short. 0.6. What is the ratio of the Exports (in Local Currency Unit) of Hong Kong in 1996 to that in 1998?
Provide a short and direct response. 1.04. What is the ratio of the Exports (in Local Currency Unit) in Nepal in 1996 to that in 1998?
Make the answer very short. 0.83. What is the ratio of the Exports (in Local Currency Unit) of Bulgaria in 1996 to that in 1999?
Your answer should be compact. 0.1. What is the ratio of the Exports (in Local Currency Unit) in Estonia in 1996 to that in 1999?
Give a very brief answer. 0.6. What is the ratio of the Exports (in Local Currency Unit) in Hong Kong in 1996 to that in 1999?
Provide a short and direct response. 1.03. What is the ratio of the Exports (in Local Currency Unit) of Nepal in 1996 to that in 1999?
Give a very brief answer. 0.73. What is the ratio of the Exports (in Local Currency Unit) in Bulgaria in 1996 to that in 2000?
Provide a succinct answer. 0.1. What is the ratio of the Exports (in Local Currency Unit) of Estonia in 1996 to that in 2000?
Ensure brevity in your answer.  0.59. What is the ratio of the Exports (in Local Currency Unit) of Hong Kong in 1996 to that in 2000?
Provide a succinct answer. 0.89. What is the ratio of the Exports (in Local Currency Unit) of Nepal in 1996 to that in 2000?
Give a very brief answer. 0.64. What is the ratio of the Exports (in Local Currency Unit) in Bulgaria in 1996 to that in 2001?
Make the answer very short. 0.1. What is the ratio of the Exports (in Local Currency Unit) of Estonia in 1996 to that in 2001?
Offer a very short reply. 0.53. What is the ratio of the Exports (in Local Currency Unit) in Hong Kong in 1996 to that in 2001?
Your answer should be very brief. 0.93. What is the ratio of the Exports (in Local Currency Unit) in Nepal in 1996 to that in 2001?
Provide a succinct answer. 0.57. What is the ratio of the Exports (in Local Currency Unit) in Bulgaria in 1996 to that in 2002?
Offer a very short reply. 0.09. What is the ratio of the Exports (in Local Currency Unit) of Estonia in 1996 to that in 2002?
Offer a terse response. 0.5. What is the ratio of the Exports (in Local Currency Unit) of Hong Kong in 1996 to that in 2002?
Provide a short and direct response. 0.88. What is the ratio of the Exports (in Local Currency Unit) of Nepal in 1996 to that in 2002?
Offer a terse response. 0.7. What is the ratio of the Exports (in Local Currency Unit) of Bulgaria in 1997 to that in 1998?
Your answer should be very brief. 0.85. What is the ratio of the Exports (in Local Currency Unit) of Estonia in 1997 to that in 1998?
Offer a terse response. 0.86. What is the ratio of the Exports (in Local Currency Unit) of Hong Kong in 1997 to that in 1998?
Provide a succinct answer. 1.09. What is the ratio of the Exports (in Local Currency Unit) in Nepal in 1997 to that in 1998?
Ensure brevity in your answer.  1.08. What is the ratio of the Exports (in Local Currency Unit) in Bulgaria in 1997 to that in 1999?
Your response must be concise. 0.88. What is the ratio of the Exports (in Local Currency Unit) of Estonia in 1997 to that in 1999?
Offer a very short reply. 0.85. What is the ratio of the Exports (in Local Currency Unit) of Hong Kong in 1997 to that in 1999?
Keep it short and to the point. 1.09. What is the ratio of the Exports (in Local Currency Unit) of Nepal in 1997 to that in 1999?
Give a very brief answer. 0.94. What is the ratio of the Exports (in Local Currency Unit) of Bulgaria in 1997 to that in 2000?
Your answer should be compact. 0.93. What is the ratio of the Exports (in Local Currency Unit) in Estonia in 1997 to that in 2000?
Provide a short and direct response. 0.85. What is the ratio of the Exports (in Local Currency Unit) in Hong Kong in 1997 to that in 2000?
Give a very brief answer. 0.94. What is the ratio of the Exports (in Local Currency Unit) of Nepal in 1997 to that in 2000?
Ensure brevity in your answer.  0.84. What is the ratio of the Exports (in Local Currency Unit) in Bulgaria in 1997 to that in 2001?
Your answer should be compact. 0.87. What is the ratio of the Exports (in Local Currency Unit) in Estonia in 1997 to that in 2001?
Give a very brief answer. 0.75. What is the ratio of the Exports (in Local Currency Unit) in Hong Kong in 1997 to that in 2001?
Give a very brief answer. 0.98. What is the ratio of the Exports (in Local Currency Unit) in Nepal in 1997 to that in 2001?
Keep it short and to the point. 0.74. What is the ratio of the Exports (in Local Currency Unit) in Bulgaria in 1997 to that in 2002?
Your response must be concise. 0.82. What is the ratio of the Exports (in Local Currency Unit) of Estonia in 1997 to that in 2002?
Your answer should be compact. 0.71. What is the ratio of the Exports (in Local Currency Unit) of Hong Kong in 1997 to that in 2002?
Provide a succinct answer. 0.93. What is the ratio of the Exports (in Local Currency Unit) in Nepal in 1997 to that in 2002?
Offer a very short reply. 0.91. What is the ratio of the Exports (in Local Currency Unit) in Bulgaria in 1998 to that in 1999?
Provide a succinct answer. 1.04. What is the ratio of the Exports (in Local Currency Unit) in Hong Kong in 1998 to that in 1999?
Provide a short and direct response. 1. What is the ratio of the Exports (in Local Currency Unit) in Nepal in 1998 to that in 1999?
Ensure brevity in your answer.  0.88. What is the ratio of the Exports (in Local Currency Unit) of Bulgaria in 1998 to that in 2000?
Ensure brevity in your answer.  1.09. What is the ratio of the Exports (in Local Currency Unit) in Estonia in 1998 to that in 2000?
Provide a short and direct response. 0.99. What is the ratio of the Exports (in Local Currency Unit) in Hong Kong in 1998 to that in 2000?
Keep it short and to the point. 0.86. What is the ratio of the Exports (in Local Currency Unit) in Nepal in 1998 to that in 2000?
Your answer should be very brief. 0.78. What is the ratio of the Exports (in Local Currency Unit) of Bulgaria in 1998 to that in 2001?
Ensure brevity in your answer.  1.03. What is the ratio of the Exports (in Local Currency Unit) in Estonia in 1998 to that in 2001?
Offer a very short reply. 0.88. What is the ratio of the Exports (in Local Currency Unit) in Hong Kong in 1998 to that in 2001?
Offer a terse response. 0.9. What is the ratio of the Exports (in Local Currency Unit) in Nepal in 1998 to that in 2001?
Your response must be concise. 0.69. What is the ratio of the Exports (in Local Currency Unit) in Bulgaria in 1998 to that in 2002?
Your response must be concise. 0.97. What is the ratio of the Exports (in Local Currency Unit) in Estonia in 1998 to that in 2002?
Offer a terse response. 0.83. What is the ratio of the Exports (in Local Currency Unit) in Hong Kong in 1998 to that in 2002?
Your answer should be very brief. 0.85. What is the ratio of the Exports (in Local Currency Unit) in Nepal in 1998 to that in 2002?
Offer a very short reply. 0.84. What is the ratio of the Exports (in Local Currency Unit) in Bulgaria in 1999 to that in 2000?
Keep it short and to the point. 1.05. What is the ratio of the Exports (in Local Currency Unit) of Estonia in 1999 to that in 2000?
Your answer should be very brief. 0.99. What is the ratio of the Exports (in Local Currency Unit) in Hong Kong in 1999 to that in 2000?
Provide a short and direct response. 0.86. What is the ratio of the Exports (in Local Currency Unit) in Nepal in 1999 to that in 2000?
Make the answer very short. 0.88. What is the ratio of the Exports (in Local Currency Unit) in Bulgaria in 1999 to that in 2001?
Ensure brevity in your answer.  0.99. What is the ratio of the Exports (in Local Currency Unit) of Estonia in 1999 to that in 2001?
Offer a terse response. 0.88. What is the ratio of the Exports (in Local Currency Unit) of Hong Kong in 1999 to that in 2001?
Provide a short and direct response. 0.9. What is the ratio of the Exports (in Local Currency Unit) in Nepal in 1999 to that in 2001?
Your answer should be compact. 0.78. What is the ratio of the Exports (in Local Currency Unit) of Bulgaria in 1999 to that in 2002?
Your answer should be compact. 0.93. What is the ratio of the Exports (in Local Currency Unit) in Estonia in 1999 to that in 2002?
Your answer should be very brief. 0.83. What is the ratio of the Exports (in Local Currency Unit) of Hong Kong in 1999 to that in 2002?
Your response must be concise. 0.85. What is the ratio of the Exports (in Local Currency Unit) of Nepal in 1999 to that in 2002?
Make the answer very short. 0.96. What is the ratio of the Exports (in Local Currency Unit) of Bulgaria in 2000 to that in 2001?
Your response must be concise. 0.94. What is the ratio of the Exports (in Local Currency Unit) of Estonia in 2000 to that in 2001?
Your response must be concise. 0.89. What is the ratio of the Exports (in Local Currency Unit) in Hong Kong in 2000 to that in 2001?
Offer a very short reply. 1.05. What is the ratio of the Exports (in Local Currency Unit) in Nepal in 2000 to that in 2001?
Provide a short and direct response. 0.89. What is the ratio of the Exports (in Local Currency Unit) of Bulgaria in 2000 to that in 2002?
Your answer should be compact. 0.89. What is the ratio of the Exports (in Local Currency Unit) in Estonia in 2000 to that in 2002?
Ensure brevity in your answer.  0.84. What is the ratio of the Exports (in Local Currency Unit) in Hong Kong in 2000 to that in 2002?
Your response must be concise. 0.99. What is the ratio of the Exports (in Local Currency Unit) of Nepal in 2000 to that in 2002?
Your response must be concise. 1.08. What is the ratio of the Exports (in Local Currency Unit) of Bulgaria in 2001 to that in 2002?
Provide a short and direct response. 0.94. What is the ratio of the Exports (in Local Currency Unit) in Estonia in 2001 to that in 2002?
Make the answer very short. 0.94. What is the ratio of the Exports (in Local Currency Unit) in Hong Kong in 2001 to that in 2002?
Your answer should be very brief. 0.95. What is the ratio of the Exports (in Local Currency Unit) in Nepal in 2001 to that in 2002?
Your answer should be compact. 1.22. What is the difference between the highest and the second highest Exports (in Local Currency Unit) in Bulgaria?
Give a very brief answer. 3.66e+08. What is the difference between the highest and the second highest Exports (in Local Currency Unit) of Estonia?
Make the answer very short. 2.54e+08. What is the difference between the highest and the second highest Exports (in Local Currency Unit) in Hong Kong?
Your answer should be compact. 1.57e+1. What is the difference between the highest and the second highest Exports (in Local Currency Unit) of Nepal?
Give a very brief answer. 1.12e+1. What is the difference between the highest and the lowest Exports (in Local Currency Unit) of Bulgaria?
Give a very brief answer. 1.04e+1. What is the difference between the highest and the lowest Exports (in Local Currency Unit) in Estonia?
Provide a short and direct response. 2.28e+09. What is the difference between the highest and the lowest Exports (in Local Currency Unit) of Hong Kong?
Your answer should be very brief. 2.86e+11. What is the difference between the highest and the lowest Exports (in Local Currency Unit) in Nepal?
Keep it short and to the point. 4.28e+1. 